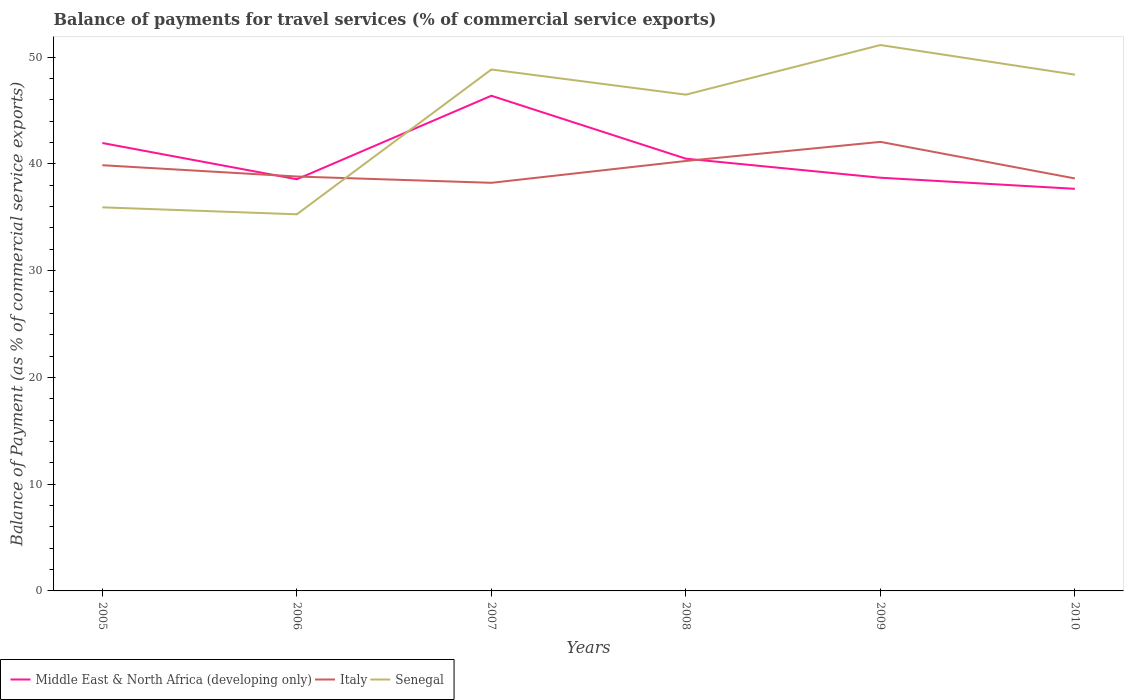Is the number of lines equal to the number of legend labels?
Your response must be concise. Yes. Across all years, what is the maximum balance of payments for travel services in Senegal?
Your answer should be compact. 35.28. In which year was the balance of payments for travel services in Italy maximum?
Provide a short and direct response. 2007. What is the total balance of payments for travel services in Middle East & North Africa (developing only) in the graph?
Offer a terse response. 8.72. What is the difference between the highest and the second highest balance of payments for travel services in Italy?
Keep it short and to the point. 3.84. Is the balance of payments for travel services in Italy strictly greater than the balance of payments for travel services in Senegal over the years?
Offer a terse response. No. How many years are there in the graph?
Provide a short and direct response. 6. What is the difference between two consecutive major ticks on the Y-axis?
Offer a terse response. 10. Does the graph contain any zero values?
Offer a terse response. No. Where does the legend appear in the graph?
Give a very brief answer. Bottom left. How are the legend labels stacked?
Your answer should be compact. Horizontal. What is the title of the graph?
Your answer should be compact. Balance of payments for travel services (% of commercial service exports). Does "San Marino" appear as one of the legend labels in the graph?
Offer a terse response. No. What is the label or title of the X-axis?
Your response must be concise. Years. What is the label or title of the Y-axis?
Offer a terse response. Balance of Payment (as % of commercial service exports). What is the Balance of Payment (as % of commercial service exports) of Middle East & North Africa (developing only) in 2005?
Give a very brief answer. 41.95. What is the Balance of Payment (as % of commercial service exports) of Italy in 2005?
Give a very brief answer. 39.87. What is the Balance of Payment (as % of commercial service exports) of Senegal in 2005?
Make the answer very short. 35.93. What is the Balance of Payment (as % of commercial service exports) in Middle East & North Africa (developing only) in 2006?
Make the answer very short. 38.56. What is the Balance of Payment (as % of commercial service exports) in Italy in 2006?
Your answer should be compact. 38.81. What is the Balance of Payment (as % of commercial service exports) in Senegal in 2006?
Your answer should be very brief. 35.28. What is the Balance of Payment (as % of commercial service exports) of Middle East & North Africa (developing only) in 2007?
Give a very brief answer. 46.38. What is the Balance of Payment (as % of commercial service exports) in Italy in 2007?
Your answer should be very brief. 38.22. What is the Balance of Payment (as % of commercial service exports) of Senegal in 2007?
Keep it short and to the point. 48.84. What is the Balance of Payment (as % of commercial service exports) of Middle East & North Africa (developing only) in 2008?
Provide a succinct answer. 40.49. What is the Balance of Payment (as % of commercial service exports) of Italy in 2008?
Ensure brevity in your answer.  40.27. What is the Balance of Payment (as % of commercial service exports) in Senegal in 2008?
Make the answer very short. 46.48. What is the Balance of Payment (as % of commercial service exports) of Middle East & North Africa (developing only) in 2009?
Ensure brevity in your answer.  38.7. What is the Balance of Payment (as % of commercial service exports) in Italy in 2009?
Keep it short and to the point. 42.06. What is the Balance of Payment (as % of commercial service exports) of Senegal in 2009?
Provide a succinct answer. 51.13. What is the Balance of Payment (as % of commercial service exports) of Middle East & North Africa (developing only) in 2010?
Provide a short and direct response. 37.66. What is the Balance of Payment (as % of commercial service exports) of Italy in 2010?
Offer a terse response. 38.64. What is the Balance of Payment (as % of commercial service exports) of Senegal in 2010?
Offer a terse response. 48.36. Across all years, what is the maximum Balance of Payment (as % of commercial service exports) in Middle East & North Africa (developing only)?
Provide a succinct answer. 46.38. Across all years, what is the maximum Balance of Payment (as % of commercial service exports) in Italy?
Make the answer very short. 42.06. Across all years, what is the maximum Balance of Payment (as % of commercial service exports) of Senegal?
Your response must be concise. 51.13. Across all years, what is the minimum Balance of Payment (as % of commercial service exports) of Middle East & North Africa (developing only)?
Provide a succinct answer. 37.66. Across all years, what is the minimum Balance of Payment (as % of commercial service exports) of Italy?
Give a very brief answer. 38.22. Across all years, what is the minimum Balance of Payment (as % of commercial service exports) in Senegal?
Offer a terse response. 35.28. What is the total Balance of Payment (as % of commercial service exports) of Middle East & North Africa (developing only) in the graph?
Your answer should be very brief. 243.74. What is the total Balance of Payment (as % of commercial service exports) in Italy in the graph?
Your answer should be very brief. 237.88. What is the total Balance of Payment (as % of commercial service exports) in Senegal in the graph?
Offer a very short reply. 266.01. What is the difference between the Balance of Payment (as % of commercial service exports) in Middle East & North Africa (developing only) in 2005 and that in 2006?
Your response must be concise. 3.4. What is the difference between the Balance of Payment (as % of commercial service exports) of Italy in 2005 and that in 2006?
Offer a very short reply. 1.06. What is the difference between the Balance of Payment (as % of commercial service exports) of Senegal in 2005 and that in 2006?
Offer a very short reply. 0.65. What is the difference between the Balance of Payment (as % of commercial service exports) of Middle East & North Africa (developing only) in 2005 and that in 2007?
Ensure brevity in your answer.  -4.43. What is the difference between the Balance of Payment (as % of commercial service exports) of Italy in 2005 and that in 2007?
Your answer should be very brief. 1.65. What is the difference between the Balance of Payment (as % of commercial service exports) in Senegal in 2005 and that in 2007?
Provide a short and direct response. -12.91. What is the difference between the Balance of Payment (as % of commercial service exports) of Middle East & North Africa (developing only) in 2005 and that in 2008?
Provide a succinct answer. 1.47. What is the difference between the Balance of Payment (as % of commercial service exports) of Italy in 2005 and that in 2008?
Ensure brevity in your answer.  -0.4. What is the difference between the Balance of Payment (as % of commercial service exports) of Senegal in 2005 and that in 2008?
Your answer should be very brief. -10.55. What is the difference between the Balance of Payment (as % of commercial service exports) in Middle East & North Africa (developing only) in 2005 and that in 2009?
Offer a very short reply. 3.25. What is the difference between the Balance of Payment (as % of commercial service exports) of Italy in 2005 and that in 2009?
Your answer should be compact. -2.19. What is the difference between the Balance of Payment (as % of commercial service exports) of Senegal in 2005 and that in 2009?
Ensure brevity in your answer.  -15.2. What is the difference between the Balance of Payment (as % of commercial service exports) of Middle East & North Africa (developing only) in 2005 and that in 2010?
Give a very brief answer. 4.29. What is the difference between the Balance of Payment (as % of commercial service exports) of Italy in 2005 and that in 2010?
Offer a terse response. 1.24. What is the difference between the Balance of Payment (as % of commercial service exports) in Senegal in 2005 and that in 2010?
Your answer should be compact. -12.43. What is the difference between the Balance of Payment (as % of commercial service exports) in Middle East & North Africa (developing only) in 2006 and that in 2007?
Your answer should be very brief. -7.82. What is the difference between the Balance of Payment (as % of commercial service exports) of Italy in 2006 and that in 2007?
Your answer should be compact. 0.59. What is the difference between the Balance of Payment (as % of commercial service exports) of Senegal in 2006 and that in 2007?
Provide a short and direct response. -13.56. What is the difference between the Balance of Payment (as % of commercial service exports) of Middle East & North Africa (developing only) in 2006 and that in 2008?
Offer a very short reply. -1.93. What is the difference between the Balance of Payment (as % of commercial service exports) of Italy in 2006 and that in 2008?
Your response must be concise. -1.46. What is the difference between the Balance of Payment (as % of commercial service exports) of Senegal in 2006 and that in 2008?
Keep it short and to the point. -11.2. What is the difference between the Balance of Payment (as % of commercial service exports) in Middle East & North Africa (developing only) in 2006 and that in 2009?
Offer a terse response. -0.14. What is the difference between the Balance of Payment (as % of commercial service exports) of Italy in 2006 and that in 2009?
Give a very brief answer. -3.25. What is the difference between the Balance of Payment (as % of commercial service exports) of Senegal in 2006 and that in 2009?
Your response must be concise. -15.85. What is the difference between the Balance of Payment (as % of commercial service exports) of Middle East & North Africa (developing only) in 2006 and that in 2010?
Ensure brevity in your answer.  0.9. What is the difference between the Balance of Payment (as % of commercial service exports) in Italy in 2006 and that in 2010?
Keep it short and to the point. 0.18. What is the difference between the Balance of Payment (as % of commercial service exports) in Senegal in 2006 and that in 2010?
Ensure brevity in your answer.  -13.08. What is the difference between the Balance of Payment (as % of commercial service exports) of Middle East & North Africa (developing only) in 2007 and that in 2008?
Your answer should be very brief. 5.89. What is the difference between the Balance of Payment (as % of commercial service exports) in Italy in 2007 and that in 2008?
Offer a very short reply. -2.05. What is the difference between the Balance of Payment (as % of commercial service exports) of Senegal in 2007 and that in 2008?
Your answer should be very brief. 2.36. What is the difference between the Balance of Payment (as % of commercial service exports) of Middle East & North Africa (developing only) in 2007 and that in 2009?
Your answer should be compact. 7.68. What is the difference between the Balance of Payment (as % of commercial service exports) in Italy in 2007 and that in 2009?
Provide a short and direct response. -3.84. What is the difference between the Balance of Payment (as % of commercial service exports) in Senegal in 2007 and that in 2009?
Your answer should be compact. -2.29. What is the difference between the Balance of Payment (as % of commercial service exports) of Middle East & North Africa (developing only) in 2007 and that in 2010?
Your answer should be compact. 8.72. What is the difference between the Balance of Payment (as % of commercial service exports) in Italy in 2007 and that in 2010?
Offer a terse response. -0.41. What is the difference between the Balance of Payment (as % of commercial service exports) in Senegal in 2007 and that in 2010?
Your answer should be very brief. 0.48. What is the difference between the Balance of Payment (as % of commercial service exports) of Middle East & North Africa (developing only) in 2008 and that in 2009?
Make the answer very short. 1.79. What is the difference between the Balance of Payment (as % of commercial service exports) in Italy in 2008 and that in 2009?
Give a very brief answer. -1.79. What is the difference between the Balance of Payment (as % of commercial service exports) in Senegal in 2008 and that in 2009?
Provide a succinct answer. -4.65. What is the difference between the Balance of Payment (as % of commercial service exports) of Middle East & North Africa (developing only) in 2008 and that in 2010?
Ensure brevity in your answer.  2.82. What is the difference between the Balance of Payment (as % of commercial service exports) in Italy in 2008 and that in 2010?
Make the answer very short. 1.63. What is the difference between the Balance of Payment (as % of commercial service exports) of Senegal in 2008 and that in 2010?
Keep it short and to the point. -1.88. What is the difference between the Balance of Payment (as % of commercial service exports) of Middle East & North Africa (developing only) in 2009 and that in 2010?
Your answer should be very brief. 1.04. What is the difference between the Balance of Payment (as % of commercial service exports) of Italy in 2009 and that in 2010?
Make the answer very short. 3.42. What is the difference between the Balance of Payment (as % of commercial service exports) of Senegal in 2009 and that in 2010?
Make the answer very short. 2.77. What is the difference between the Balance of Payment (as % of commercial service exports) of Middle East & North Africa (developing only) in 2005 and the Balance of Payment (as % of commercial service exports) of Italy in 2006?
Ensure brevity in your answer.  3.14. What is the difference between the Balance of Payment (as % of commercial service exports) in Middle East & North Africa (developing only) in 2005 and the Balance of Payment (as % of commercial service exports) in Senegal in 2006?
Your answer should be very brief. 6.68. What is the difference between the Balance of Payment (as % of commercial service exports) of Italy in 2005 and the Balance of Payment (as % of commercial service exports) of Senegal in 2006?
Provide a short and direct response. 4.6. What is the difference between the Balance of Payment (as % of commercial service exports) of Middle East & North Africa (developing only) in 2005 and the Balance of Payment (as % of commercial service exports) of Italy in 2007?
Your answer should be compact. 3.73. What is the difference between the Balance of Payment (as % of commercial service exports) of Middle East & North Africa (developing only) in 2005 and the Balance of Payment (as % of commercial service exports) of Senegal in 2007?
Your answer should be very brief. -6.89. What is the difference between the Balance of Payment (as % of commercial service exports) in Italy in 2005 and the Balance of Payment (as % of commercial service exports) in Senegal in 2007?
Give a very brief answer. -8.97. What is the difference between the Balance of Payment (as % of commercial service exports) in Middle East & North Africa (developing only) in 2005 and the Balance of Payment (as % of commercial service exports) in Italy in 2008?
Give a very brief answer. 1.68. What is the difference between the Balance of Payment (as % of commercial service exports) in Middle East & North Africa (developing only) in 2005 and the Balance of Payment (as % of commercial service exports) in Senegal in 2008?
Ensure brevity in your answer.  -4.53. What is the difference between the Balance of Payment (as % of commercial service exports) of Italy in 2005 and the Balance of Payment (as % of commercial service exports) of Senegal in 2008?
Your answer should be very brief. -6.61. What is the difference between the Balance of Payment (as % of commercial service exports) of Middle East & North Africa (developing only) in 2005 and the Balance of Payment (as % of commercial service exports) of Italy in 2009?
Your answer should be compact. -0.11. What is the difference between the Balance of Payment (as % of commercial service exports) in Middle East & North Africa (developing only) in 2005 and the Balance of Payment (as % of commercial service exports) in Senegal in 2009?
Give a very brief answer. -9.18. What is the difference between the Balance of Payment (as % of commercial service exports) in Italy in 2005 and the Balance of Payment (as % of commercial service exports) in Senegal in 2009?
Your answer should be very brief. -11.26. What is the difference between the Balance of Payment (as % of commercial service exports) of Middle East & North Africa (developing only) in 2005 and the Balance of Payment (as % of commercial service exports) of Italy in 2010?
Keep it short and to the point. 3.32. What is the difference between the Balance of Payment (as % of commercial service exports) in Middle East & North Africa (developing only) in 2005 and the Balance of Payment (as % of commercial service exports) in Senegal in 2010?
Make the answer very short. -6.4. What is the difference between the Balance of Payment (as % of commercial service exports) in Italy in 2005 and the Balance of Payment (as % of commercial service exports) in Senegal in 2010?
Your answer should be very brief. -8.48. What is the difference between the Balance of Payment (as % of commercial service exports) of Middle East & North Africa (developing only) in 2006 and the Balance of Payment (as % of commercial service exports) of Italy in 2007?
Your response must be concise. 0.33. What is the difference between the Balance of Payment (as % of commercial service exports) of Middle East & North Africa (developing only) in 2006 and the Balance of Payment (as % of commercial service exports) of Senegal in 2007?
Your answer should be very brief. -10.28. What is the difference between the Balance of Payment (as % of commercial service exports) of Italy in 2006 and the Balance of Payment (as % of commercial service exports) of Senegal in 2007?
Your response must be concise. -10.02. What is the difference between the Balance of Payment (as % of commercial service exports) in Middle East & North Africa (developing only) in 2006 and the Balance of Payment (as % of commercial service exports) in Italy in 2008?
Offer a very short reply. -1.71. What is the difference between the Balance of Payment (as % of commercial service exports) in Middle East & North Africa (developing only) in 2006 and the Balance of Payment (as % of commercial service exports) in Senegal in 2008?
Ensure brevity in your answer.  -7.92. What is the difference between the Balance of Payment (as % of commercial service exports) of Italy in 2006 and the Balance of Payment (as % of commercial service exports) of Senegal in 2008?
Your answer should be very brief. -7.67. What is the difference between the Balance of Payment (as % of commercial service exports) of Middle East & North Africa (developing only) in 2006 and the Balance of Payment (as % of commercial service exports) of Italy in 2009?
Your answer should be very brief. -3.5. What is the difference between the Balance of Payment (as % of commercial service exports) of Middle East & North Africa (developing only) in 2006 and the Balance of Payment (as % of commercial service exports) of Senegal in 2009?
Your response must be concise. -12.57. What is the difference between the Balance of Payment (as % of commercial service exports) in Italy in 2006 and the Balance of Payment (as % of commercial service exports) in Senegal in 2009?
Offer a very short reply. -12.31. What is the difference between the Balance of Payment (as % of commercial service exports) in Middle East & North Africa (developing only) in 2006 and the Balance of Payment (as % of commercial service exports) in Italy in 2010?
Your answer should be very brief. -0.08. What is the difference between the Balance of Payment (as % of commercial service exports) of Middle East & North Africa (developing only) in 2006 and the Balance of Payment (as % of commercial service exports) of Senegal in 2010?
Keep it short and to the point. -9.8. What is the difference between the Balance of Payment (as % of commercial service exports) in Italy in 2006 and the Balance of Payment (as % of commercial service exports) in Senegal in 2010?
Keep it short and to the point. -9.54. What is the difference between the Balance of Payment (as % of commercial service exports) of Middle East & North Africa (developing only) in 2007 and the Balance of Payment (as % of commercial service exports) of Italy in 2008?
Give a very brief answer. 6.11. What is the difference between the Balance of Payment (as % of commercial service exports) in Middle East & North Africa (developing only) in 2007 and the Balance of Payment (as % of commercial service exports) in Senegal in 2008?
Offer a terse response. -0.1. What is the difference between the Balance of Payment (as % of commercial service exports) of Italy in 2007 and the Balance of Payment (as % of commercial service exports) of Senegal in 2008?
Your response must be concise. -8.26. What is the difference between the Balance of Payment (as % of commercial service exports) of Middle East & North Africa (developing only) in 2007 and the Balance of Payment (as % of commercial service exports) of Italy in 2009?
Provide a short and direct response. 4.32. What is the difference between the Balance of Payment (as % of commercial service exports) in Middle East & North Africa (developing only) in 2007 and the Balance of Payment (as % of commercial service exports) in Senegal in 2009?
Offer a terse response. -4.75. What is the difference between the Balance of Payment (as % of commercial service exports) in Italy in 2007 and the Balance of Payment (as % of commercial service exports) in Senegal in 2009?
Provide a short and direct response. -12.9. What is the difference between the Balance of Payment (as % of commercial service exports) of Middle East & North Africa (developing only) in 2007 and the Balance of Payment (as % of commercial service exports) of Italy in 2010?
Your answer should be compact. 7.74. What is the difference between the Balance of Payment (as % of commercial service exports) of Middle East & North Africa (developing only) in 2007 and the Balance of Payment (as % of commercial service exports) of Senegal in 2010?
Your response must be concise. -1.98. What is the difference between the Balance of Payment (as % of commercial service exports) of Italy in 2007 and the Balance of Payment (as % of commercial service exports) of Senegal in 2010?
Make the answer very short. -10.13. What is the difference between the Balance of Payment (as % of commercial service exports) in Middle East & North Africa (developing only) in 2008 and the Balance of Payment (as % of commercial service exports) in Italy in 2009?
Provide a succinct answer. -1.57. What is the difference between the Balance of Payment (as % of commercial service exports) of Middle East & North Africa (developing only) in 2008 and the Balance of Payment (as % of commercial service exports) of Senegal in 2009?
Give a very brief answer. -10.64. What is the difference between the Balance of Payment (as % of commercial service exports) of Italy in 2008 and the Balance of Payment (as % of commercial service exports) of Senegal in 2009?
Make the answer very short. -10.86. What is the difference between the Balance of Payment (as % of commercial service exports) in Middle East & North Africa (developing only) in 2008 and the Balance of Payment (as % of commercial service exports) in Italy in 2010?
Give a very brief answer. 1.85. What is the difference between the Balance of Payment (as % of commercial service exports) in Middle East & North Africa (developing only) in 2008 and the Balance of Payment (as % of commercial service exports) in Senegal in 2010?
Ensure brevity in your answer.  -7.87. What is the difference between the Balance of Payment (as % of commercial service exports) of Italy in 2008 and the Balance of Payment (as % of commercial service exports) of Senegal in 2010?
Ensure brevity in your answer.  -8.09. What is the difference between the Balance of Payment (as % of commercial service exports) in Middle East & North Africa (developing only) in 2009 and the Balance of Payment (as % of commercial service exports) in Italy in 2010?
Offer a very short reply. 0.07. What is the difference between the Balance of Payment (as % of commercial service exports) in Middle East & North Africa (developing only) in 2009 and the Balance of Payment (as % of commercial service exports) in Senegal in 2010?
Your answer should be compact. -9.66. What is the difference between the Balance of Payment (as % of commercial service exports) of Italy in 2009 and the Balance of Payment (as % of commercial service exports) of Senegal in 2010?
Offer a terse response. -6.3. What is the average Balance of Payment (as % of commercial service exports) in Middle East & North Africa (developing only) per year?
Keep it short and to the point. 40.62. What is the average Balance of Payment (as % of commercial service exports) in Italy per year?
Give a very brief answer. 39.65. What is the average Balance of Payment (as % of commercial service exports) in Senegal per year?
Offer a very short reply. 44.34. In the year 2005, what is the difference between the Balance of Payment (as % of commercial service exports) in Middle East & North Africa (developing only) and Balance of Payment (as % of commercial service exports) in Italy?
Keep it short and to the point. 2.08. In the year 2005, what is the difference between the Balance of Payment (as % of commercial service exports) of Middle East & North Africa (developing only) and Balance of Payment (as % of commercial service exports) of Senegal?
Make the answer very short. 6.02. In the year 2005, what is the difference between the Balance of Payment (as % of commercial service exports) in Italy and Balance of Payment (as % of commercial service exports) in Senegal?
Provide a succinct answer. 3.94. In the year 2006, what is the difference between the Balance of Payment (as % of commercial service exports) of Middle East & North Africa (developing only) and Balance of Payment (as % of commercial service exports) of Italy?
Ensure brevity in your answer.  -0.26. In the year 2006, what is the difference between the Balance of Payment (as % of commercial service exports) of Middle East & North Africa (developing only) and Balance of Payment (as % of commercial service exports) of Senegal?
Your response must be concise. 3.28. In the year 2006, what is the difference between the Balance of Payment (as % of commercial service exports) of Italy and Balance of Payment (as % of commercial service exports) of Senegal?
Make the answer very short. 3.54. In the year 2007, what is the difference between the Balance of Payment (as % of commercial service exports) in Middle East & North Africa (developing only) and Balance of Payment (as % of commercial service exports) in Italy?
Ensure brevity in your answer.  8.16. In the year 2007, what is the difference between the Balance of Payment (as % of commercial service exports) in Middle East & North Africa (developing only) and Balance of Payment (as % of commercial service exports) in Senegal?
Your answer should be compact. -2.46. In the year 2007, what is the difference between the Balance of Payment (as % of commercial service exports) in Italy and Balance of Payment (as % of commercial service exports) in Senegal?
Your answer should be compact. -10.62. In the year 2008, what is the difference between the Balance of Payment (as % of commercial service exports) in Middle East & North Africa (developing only) and Balance of Payment (as % of commercial service exports) in Italy?
Your answer should be compact. 0.22. In the year 2008, what is the difference between the Balance of Payment (as % of commercial service exports) in Middle East & North Africa (developing only) and Balance of Payment (as % of commercial service exports) in Senegal?
Give a very brief answer. -5.99. In the year 2008, what is the difference between the Balance of Payment (as % of commercial service exports) in Italy and Balance of Payment (as % of commercial service exports) in Senegal?
Offer a terse response. -6.21. In the year 2009, what is the difference between the Balance of Payment (as % of commercial service exports) of Middle East & North Africa (developing only) and Balance of Payment (as % of commercial service exports) of Italy?
Offer a very short reply. -3.36. In the year 2009, what is the difference between the Balance of Payment (as % of commercial service exports) in Middle East & North Africa (developing only) and Balance of Payment (as % of commercial service exports) in Senegal?
Provide a succinct answer. -12.43. In the year 2009, what is the difference between the Balance of Payment (as % of commercial service exports) of Italy and Balance of Payment (as % of commercial service exports) of Senegal?
Give a very brief answer. -9.07. In the year 2010, what is the difference between the Balance of Payment (as % of commercial service exports) of Middle East & North Africa (developing only) and Balance of Payment (as % of commercial service exports) of Italy?
Your answer should be compact. -0.97. In the year 2010, what is the difference between the Balance of Payment (as % of commercial service exports) in Middle East & North Africa (developing only) and Balance of Payment (as % of commercial service exports) in Senegal?
Your response must be concise. -10.69. In the year 2010, what is the difference between the Balance of Payment (as % of commercial service exports) of Italy and Balance of Payment (as % of commercial service exports) of Senegal?
Your response must be concise. -9.72. What is the ratio of the Balance of Payment (as % of commercial service exports) of Middle East & North Africa (developing only) in 2005 to that in 2006?
Your response must be concise. 1.09. What is the ratio of the Balance of Payment (as % of commercial service exports) in Italy in 2005 to that in 2006?
Offer a very short reply. 1.03. What is the ratio of the Balance of Payment (as % of commercial service exports) in Senegal in 2005 to that in 2006?
Your answer should be very brief. 1.02. What is the ratio of the Balance of Payment (as % of commercial service exports) in Middle East & North Africa (developing only) in 2005 to that in 2007?
Provide a short and direct response. 0.9. What is the ratio of the Balance of Payment (as % of commercial service exports) of Italy in 2005 to that in 2007?
Keep it short and to the point. 1.04. What is the ratio of the Balance of Payment (as % of commercial service exports) in Senegal in 2005 to that in 2007?
Give a very brief answer. 0.74. What is the ratio of the Balance of Payment (as % of commercial service exports) of Middle East & North Africa (developing only) in 2005 to that in 2008?
Give a very brief answer. 1.04. What is the ratio of the Balance of Payment (as % of commercial service exports) of Italy in 2005 to that in 2008?
Ensure brevity in your answer.  0.99. What is the ratio of the Balance of Payment (as % of commercial service exports) in Senegal in 2005 to that in 2008?
Give a very brief answer. 0.77. What is the ratio of the Balance of Payment (as % of commercial service exports) of Middle East & North Africa (developing only) in 2005 to that in 2009?
Your response must be concise. 1.08. What is the ratio of the Balance of Payment (as % of commercial service exports) in Italy in 2005 to that in 2009?
Provide a succinct answer. 0.95. What is the ratio of the Balance of Payment (as % of commercial service exports) in Senegal in 2005 to that in 2009?
Make the answer very short. 0.7. What is the ratio of the Balance of Payment (as % of commercial service exports) of Middle East & North Africa (developing only) in 2005 to that in 2010?
Offer a terse response. 1.11. What is the ratio of the Balance of Payment (as % of commercial service exports) of Italy in 2005 to that in 2010?
Your answer should be compact. 1.03. What is the ratio of the Balance of Payment (as % of commercial service exports) of Senegal in 2005 to that in 2010?
Provide a short and direct response. 0.74. What is the ratio of the Balance of Payment (as % of commercial service exports) in Middle East & North Africa (developing only) in 2006 to that in 2007?
Your answer should be very brief. 0.83. What is the ratio of the Balance of Payment (as % of commercial service exports) of Italy in 2006 to that in 2007?
Keep it short and to the point. 1.02. What is the ratio of the Balance of Payment (as % of commercial service exports) of Senegal in 2006 to that in 2007?
Offer a terse response. 0.72. What is the ratio of the Balance of Payment (as % of commercial service exports) of Italy in 2006 to that in 2008?
Offer a terse response. 0.96. What is the ratio of the Balance of Payment (as % of commercial service exports) in Senegal in 2006 to that in 2008?
Offer a very short reply. 0.76. What is the ratio of the Balance of Payment (as % of commercial service exports) of Italy in 2006 to that in 2009?
Provide a succinct answer. 0.92. What is the ratio of the Balance of Payment (as % of commercial service exports) of Senegal in 2006 to that in 2009?
Your answer should be very brief. 0.69. What is the ratio of the Balance of Payment (as % of commercial service exports) of Middle East & North Africa (developing only) in 2006 to that in 2010?
Provide a short and direct response. 1.02. What is the ratio of the Balance of Payment (as % of commercial service exports) in Senegal in 2006 to that in 2010?
Keep it short and to the point. 0.73. What is the ratio of the Balance of Payment (as % of commercial service exports) of Middle East & North Africa (developing only) in 2007 to that in 2008?
Your response must be concise. 1.15. What is the ratio of the Balance of Payment (as % of commercial service exports) of Italy in 2007 to that in 2008?
Your answer should be very brief. 0.95. What is the ratio of the Balance of Payment (as % of commercial service exports) in Senegal in 2007 to that in 2008?
Give a very brief answer. 1.05. What is the ratio of the Balance of Payment (as % of commercial service exports) in Middle East & North Africa (developing only) in 2007 to that in 2009?
Ensure brevity in your answer.  1.2. What is the ratio of the Balance of Payment (as % of commercial service exports) in Italy in 2007 to that in 2009?
Provide a succinct answer. 0.91. What is the ratio of the Balance of Payment (as % of commercial service exports) in Senegal in 2007 to that in 2009?
Provide a succinct answer. 0.96. What is the ratio of the Balance of Payment (as % of commercial service exports) in Middle East & North Africa (developing only) in 2007 to that in 2010?
Offer a terse response. 1.23. What is the ratio of the Balance of Payment (as % of commercial service exports) in Senegal in 2007 to that in 2010?
Offer a very short reply. 1.01. What is the ratio of the Balance of Payment (as % of commercial service exports) of Middle East & North Africa (developing only) in 2008 to that in 2009?
Provide a succinct answer. 1.05. What is the ratio of the Balance of Payment (as % of commercial service exports) of Italy in 2008 to that in 2009?
Keep it short and to the point. 0.96. What is the ratio of the Balance of Payment (as % of commercial service exports) in Senegal in 2008 to that in 2009?
Offer a very short reply. 0.91. What is the ratio of the Balance of Payment (as % of commercial service exports) in Middle East & North Africa (developing only) in 2008 to that in 2010?
Make the answer very short. 1.07. What is the ratio of the Balance of Payment (as % of commercial service exports) of Italy in 2008 to that in 2010?
Offer a terse response. 1.04. What is the ratio of the Balance of Payment (as % of commercial service exports) in Senegal in 2008 to that in 2010?
Make the answer very short. 0.96. What is the ratio of the Balance of Payment (as % of commercial service exports) of Middle East & North Africa (developing only) in 2009 to that in 2010?
Your answer should be very brief. 1.03. What is the ratio of the Balance of Payment (as % of commercial service exports) in Italy in 2009 to that in 2010?
Provide a succinct answer. 1.09. What is the ratio of the Balance of Payment (as % of commercial service exports) in Senegal in 2009 to that in 2010?
Provide a short and direct response. 1.06. What is the difference between the highest and the second highest Balance of Payment (as % of commercial service exports) of Middle East & North Africa (developing only)?
Keep it short and to the point. 4.43. What is the difference between the highest and the second highest Balance of Payment (as % of commercial service exports) in Italy?
Your answer should be compact. 1.79. What is the difference between the highest and the second highest Balance of Payment (as % of commercial service exports) in Senegal?
Ensure brevity in your answer.  2.29. What is the difference between the highest and the lowest Balance of Payment (as % of commercial service exports) of Middle East & North Africa (developing only)?
Give a very brief answer. 8.72. What is the difference between the highest and the lowest Balance of Payment (as % of commercial service exports) of Italy?
Give a very brief answer. 3.84. What is the difference between the highest and the lowest Balance of Payment (as % of commercial service exports) of Senegal?
Give a very brief answer. 15.85. 